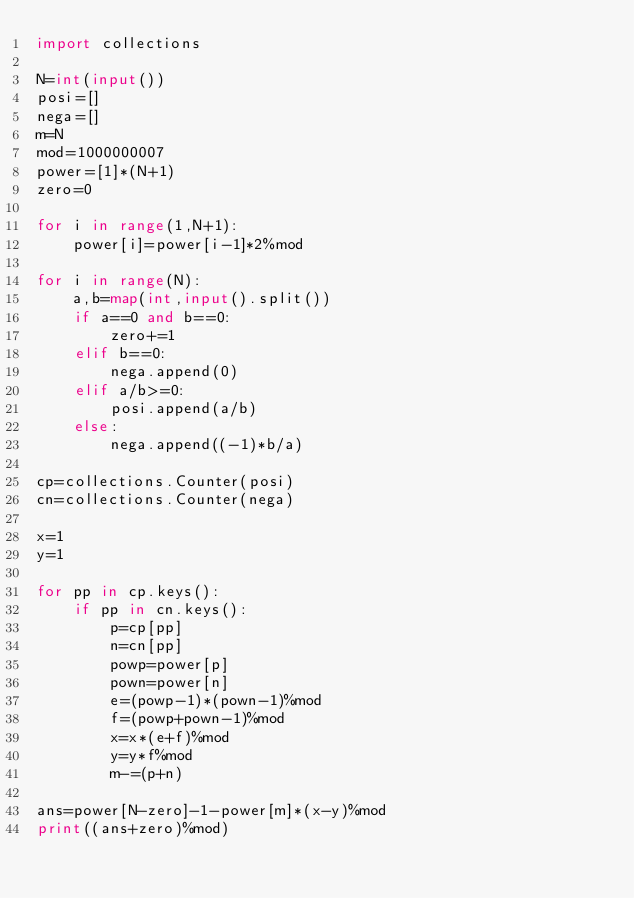Convert code to text. <code><loc_0><loc_0><loc_500><loc_500><_Python_>import collections

N=int(input())
posi=[]
nega=[]
m=N
mod=1000000007
power=[1]*(N+1)
zero=0

for i in range(1,N+1):
    power[i]=power[i-1]*2%mod
    
for i in range(N):
    a,b=map(int,input().split())
    if a==0 and b==0:
        zero+=1
    elif b==0:
        nega.append(0)
    elif a/b>=0:
        posi.append(a/b)
    else:
        nega.append((-1)*b/a)

cp=collections.Counter(posi)
cn=collections.Counter(nega)

x=1
y=1

for pp in cp.keys():
    if pp in cn.keys():
        p=cp[pp]
        n=cn[pp]
        powp=power[p]
        pown=power[n]
        e=(powp-1)*(pown-1)%mod
        f=(powp+pown-1)%mod
        x=x*(e+f)%mod
        y=y*f%mod
        m-=(p+n)

ans=power[N-zero]-1-power[m]*(x-y)%mod
print((ans+zero)%mod)    </code> 